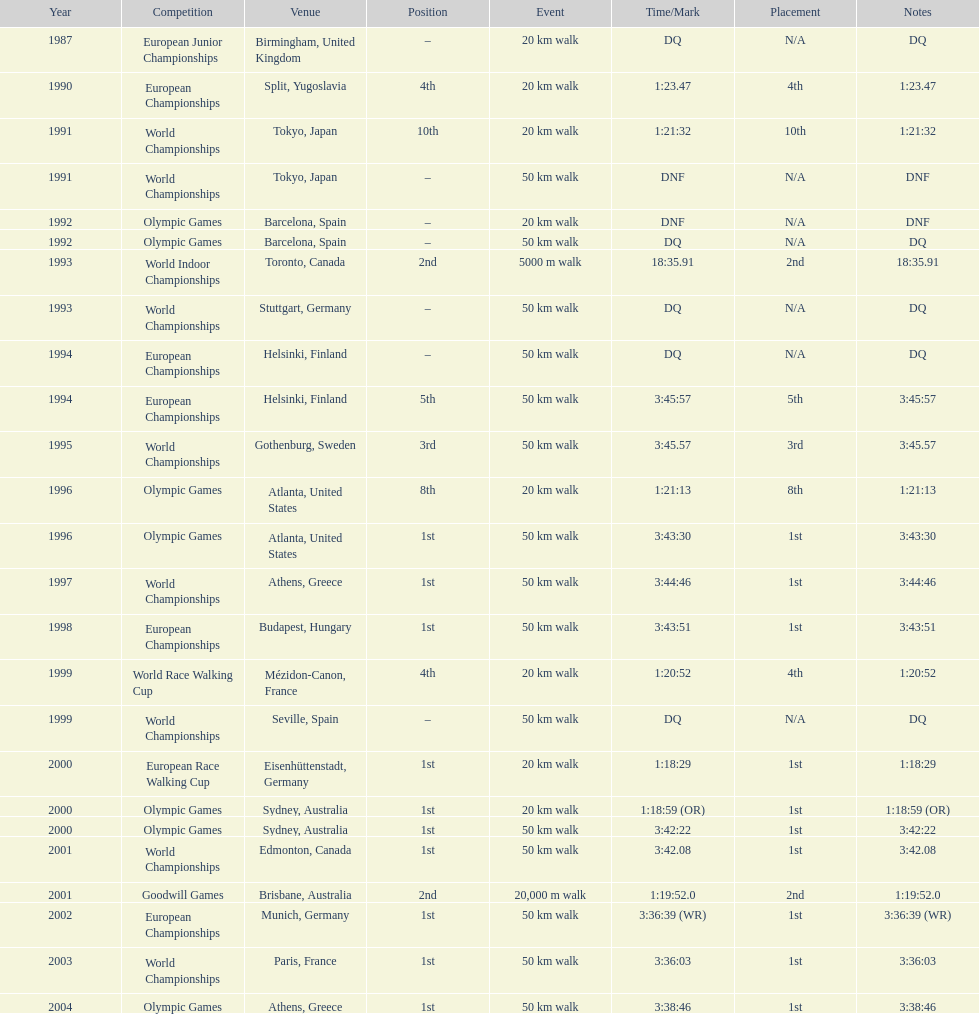How many occurrences was the premier position mentioned as the rank? 10. 